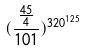Convert formula to latex. <formula><loc_0><loc_0><loc_500><loc_500>( \frac { \frac { 4 5 } { 4 } } { 1 0 1 } ) ^ { 3 2 0 ^ { 1 2 5 } }</formula> 